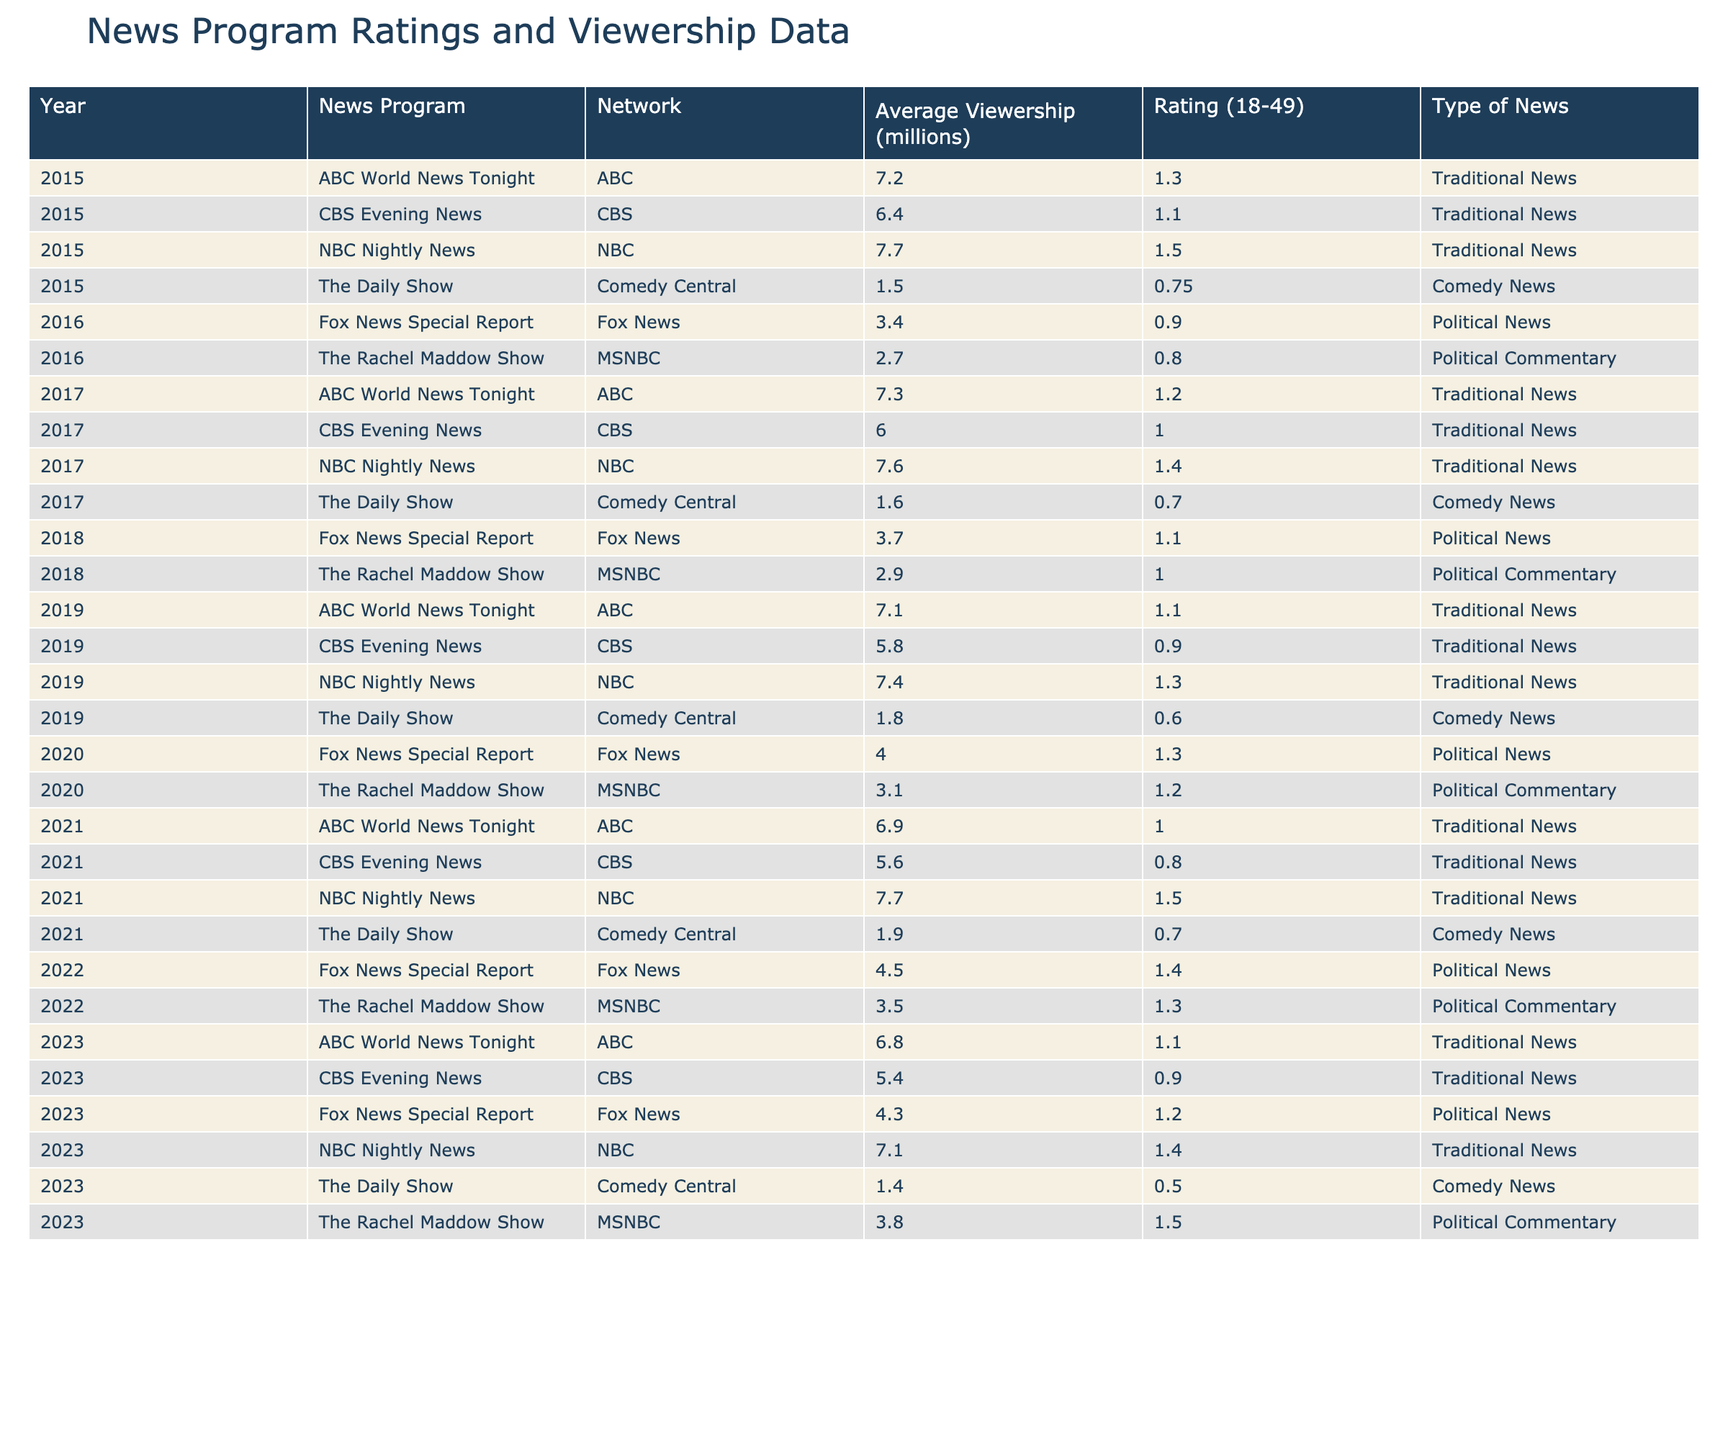What year did "The Daily Show" have the lowest average viewership? By reviewing the viewership data for "The Daily Show," we see that in 2023 it had an average viewership of 1.4 million, which is lower than all previous years listed.
Answer: 2023 Which news program had the highest average viewership in 2016? In 2016, "NBC Nightly News" had the highest average viewership at 7.7 million, compared to the other programs that year.
Answer: NBC Nightly News What was the average rating (18-49) for "ABC World News Tonight" from 2015 to 2023? To calculate the average rating for "ABC World News Tonight," we take the ratings from each year: 1.3 (2015), 1.2 (2017), 1.1 (2019), 1.0 (2021), 1.1 (2023). The sum is 5.7, and with 5 data points, the average rating is 5.7/5 = 1.14.
Answer: 1.14 Did "The Rachel Maddow Show" have a consistent increase in average viewership from 2015 to 2023? By examining the viewership data for "The Rachel Maddow Show," we see it started at 2.7 million in 2016, increased to 3.1 million in 2020, and peaked at 3.8 million in 2023. However, there were lower values in 2017 (2.9 million) and 2018 (3.1 million). Thus, it was not consistent.
Answer: No What is the difference in average viewership between "CBS Evening News" in 2015 and 2023? The average viewership for "CBS Evening News" in 2015 was 6.4 million, and in 2023 it was 5.4 million. The difference is 6.4 - 5.4 = 1 million.
Answer: 1 million Which network consistently had the highest ratings for its news programs from 2015 to 2023? Analyzing the ratings over the years, NBC Nightly News consistently had higher ratings compared to the other news programs during the given years.
Answer: NBC What was the trend of average viewership for "Fox News Special Report" from 2015 to 2023? Reviewing the viewership data, "Fox News Special Report" had values of 3.4 million in 2016, increasing to 4.0 million in 2020 and then to 4.5 million in 2022 but slightly decreased to 4.3 million in 2023. Overall, it shows an upward trend with a minor decline in the last year.
Answer: Upward trend with slight decline in 2023 What was the average rating for all news programs in 2022? Calculating the average rating for all programs in 2022: The ratings are 1.3 (The Rachel Maddow Show), 1.4 (Fox News Special Report), 1.5 (NBC Nightly News), 1.0 (ABC World News Tonight), and 0.8 (CBS Evening News). The sum is 5.5, and with 5 programs, the average is 5.5 / 5 = 1.1.
Answer: 1.1 